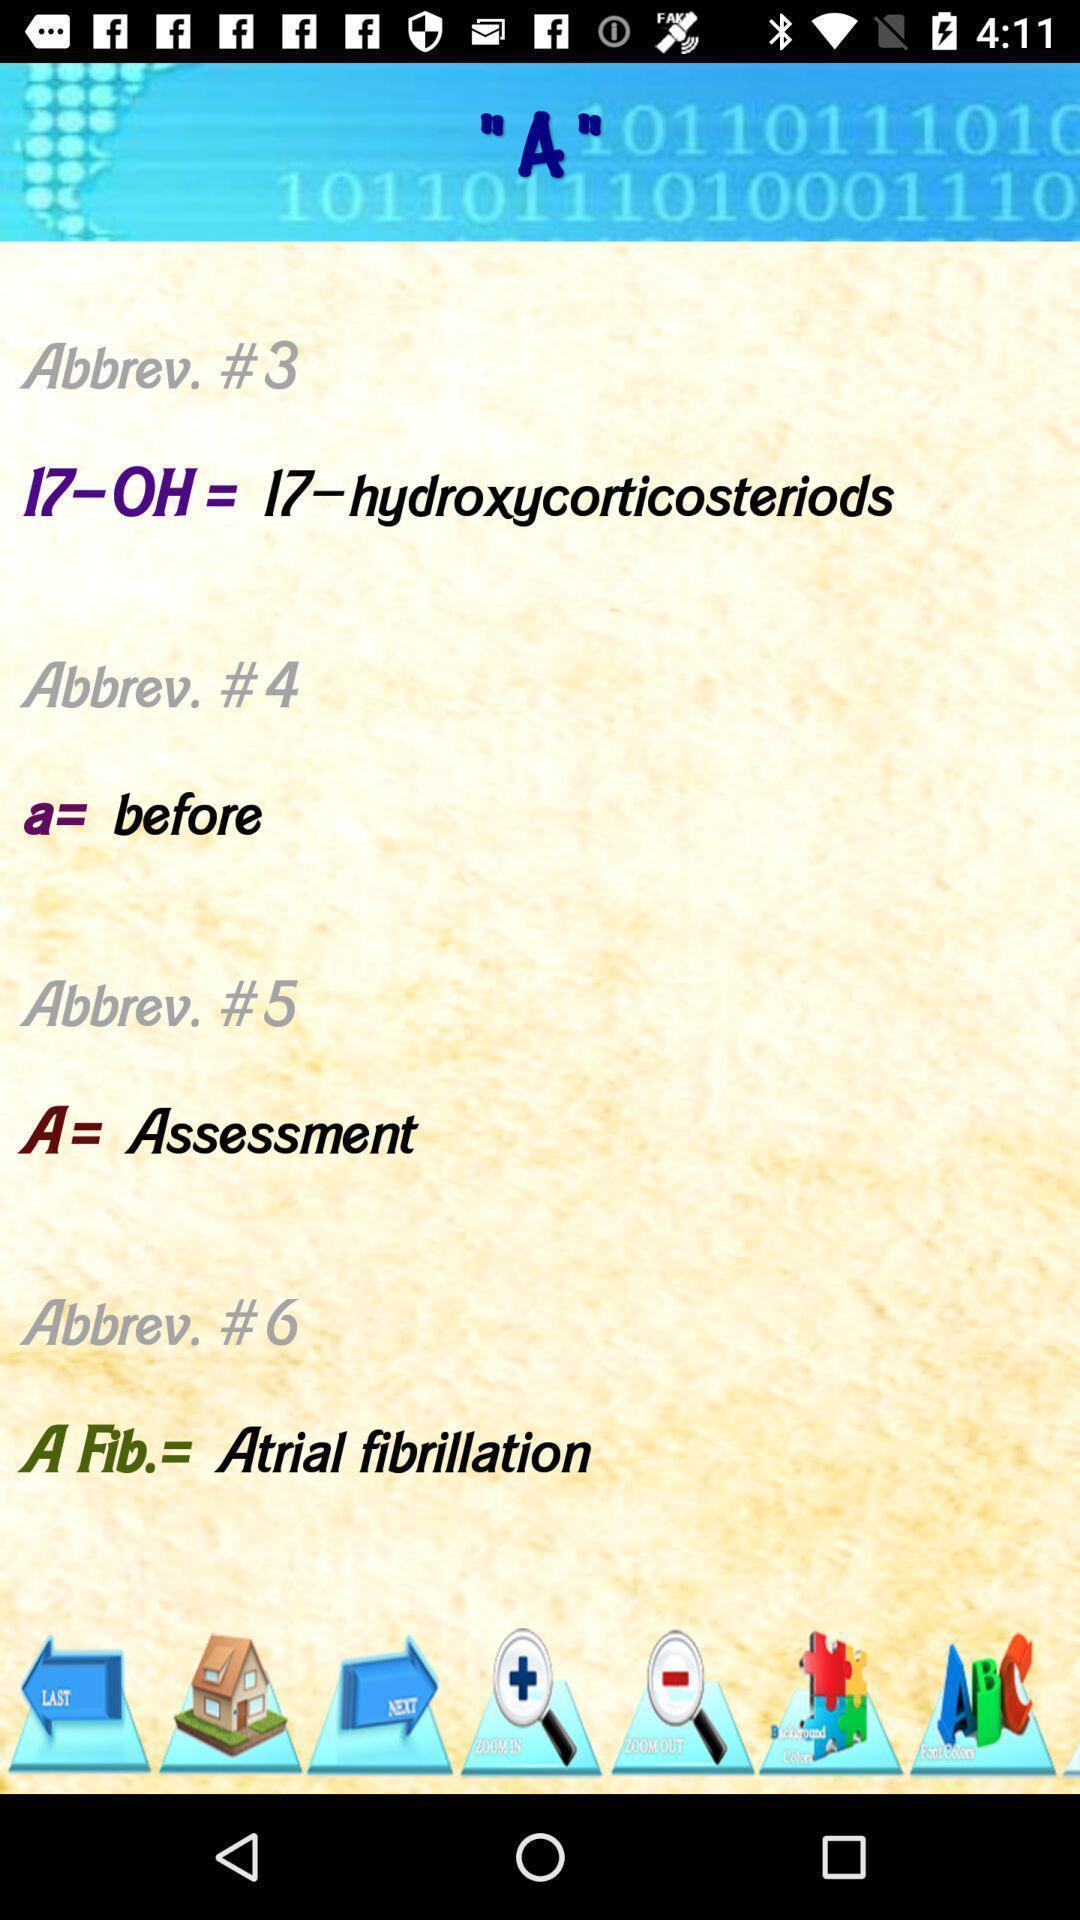Summarize the information in this screenshot. Page showing list of various abbreviations. 